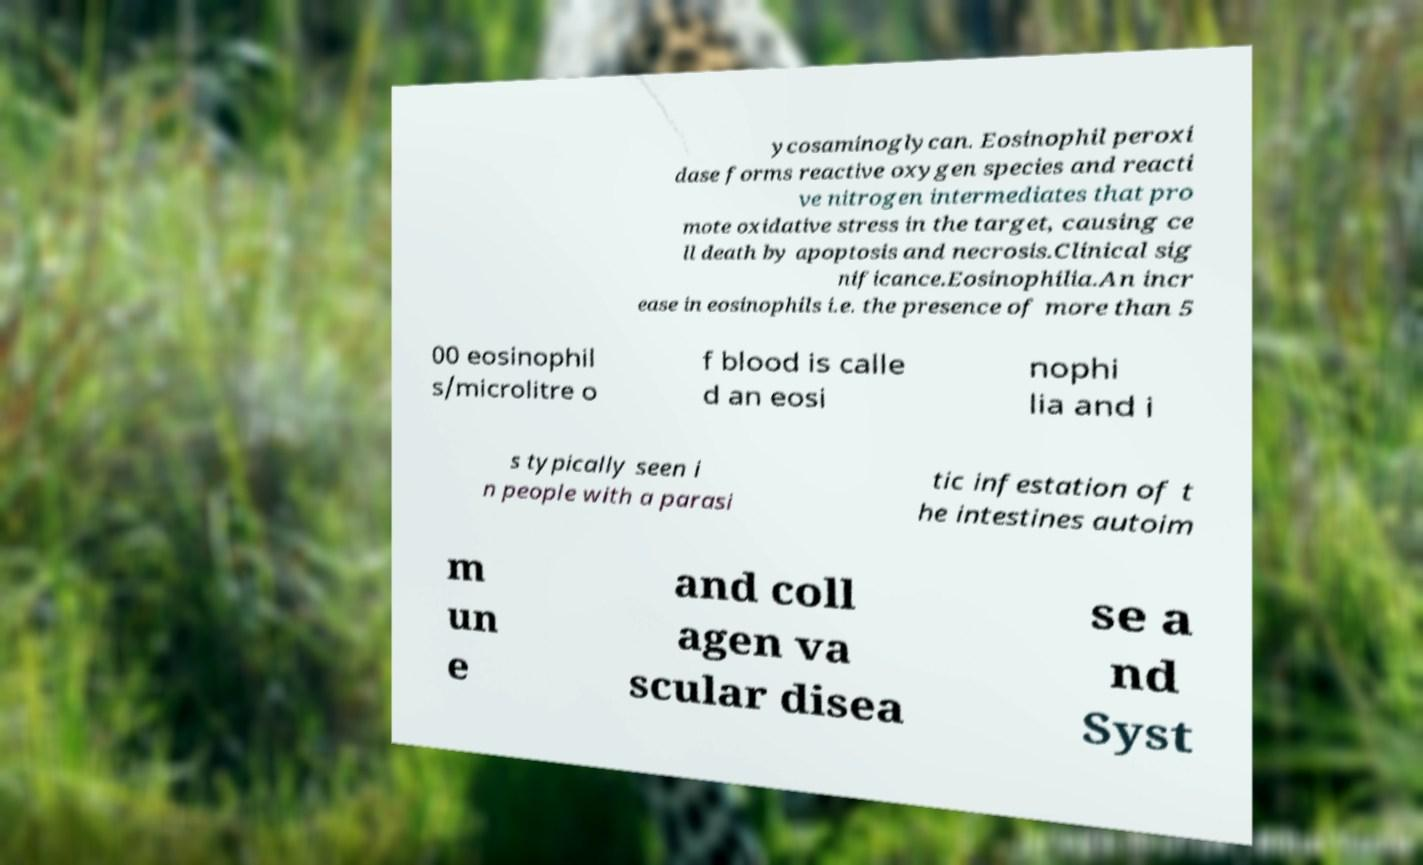I need the written content from this picture converted into text. Can you do that? ycosaminoglycan. Eosinophil peroxi dase forms reactive oxygen species and reacti ve nitrogen intermediates that pro mote oxidative stress in the target, causing ce ll death by apoptosis and necrosis.Clinical sig nificance.Eosinophilia.An incr ease in eosinophils i.e. the presence of more than 5 00 eosinophil s/microlitre o f blood is calle d an eosi nophi lia and i s typically seen i n people with a parasi tic infestation of t he intestines autoim m un e and coll agen va scular disea se a nd Syst 